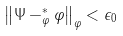<formula> <loc_0><loc_0><loc_500><loc_500>\left \| \Psi - ^ { * } _ { \varphi } \varphi \right \| _ { \varphi } < \epsilon _ { 0 }</formula> 